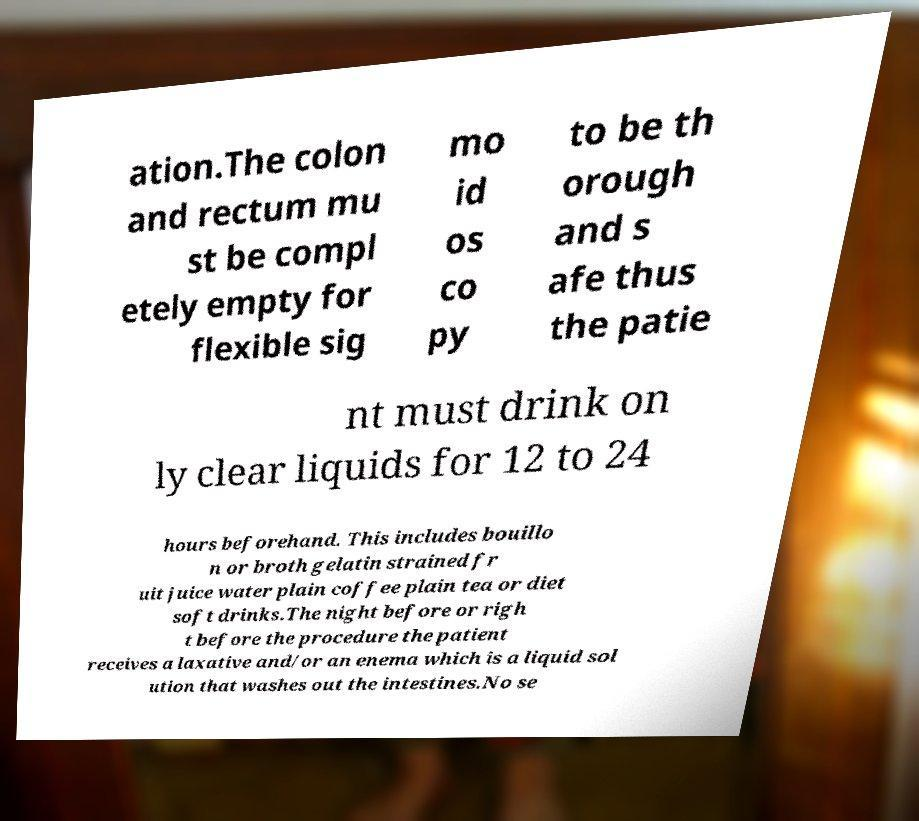What messages or text are displayed in this image? I need them in a readable, typed format. ation.The colon and rectum mu st be compl etely empty for flexible sig mo id os co py to be th orough and s afe thus the patie nt must drink on ly clear liquids for 12 to 24 hours beforehand. This includes bouillo n or broth gelatin strained fr uit juice water plain coffee plain tea or diet soft drinks.The night before or righ t before the procedure the patient receives a laxative and/or an enema which is a liquid sol ution that washes out the intestines.No se 